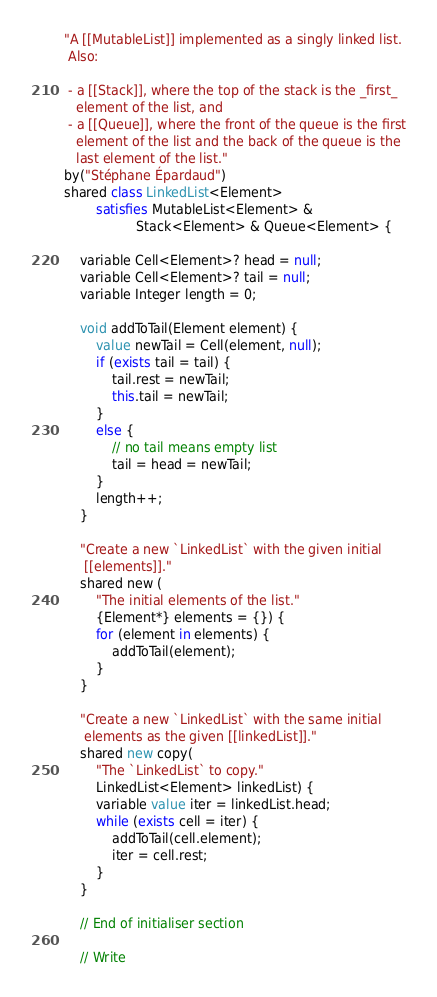Convert code to text. <code><loc_0><loc_0><loc_500><loc_500><_Ceylon_>"A [[MutableList]] implemented as a singly linked list.
 Also:

 - a [[Stack]], where the top of the stack is the _first_
   element of the list, and
 - a [[Queue]], where the front of the queue is the first
   element of the list and the back of the queue is the
   last element of the list."
by("Stéphane Épardaud")
shared class LinkedList<Element>
        satisfies MutableList<Element> &
                  Stack<Element> & Queue<Element> {

    variable Cell<Element>? head = null;
    variable Cell<Element>? tail = null;
    variable Integer length = 0;
    
    void addToTail(Element element) {
        value newTail = Cell(element, null);
        if (exists tail = tail) {
            tail.rest = newTail;
            this.tail = newTail;
        }
        else {
            // no tail means empty list
            tail = head = newTail;
        }
        length++;
    }
    
    "Create a new `LinkedList` with the given initial 
     [[elements]]."
    shared new (
        "The initial elements of the list."
        {Element*} elements = {}) {
        for (element in elements) {
            addToTail(element);
        }
    }
    
    "Create a new `LinkedList` with the same initial 
     elements as the given [[linkedList]]."
    shared new copy(
        "The `LinkedList` to copy."
        LinkedList<Element> linkedList) {
        variable value iter = linkedList.head;
        while (exists cell = iter) {
            addToTail(cell.element);
            iter = cell.rest;
        }
    }
    
    // End of initialiser section

    // Write
</code> 